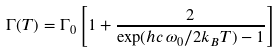Convert formula to latex. <formula><loc_0><loc_0><loc_500><loc_500>\Gamma ( T ) = \Gamma _ { 0 } \left [ 1 + \frac { 2 } { \exp ( h c \, \omega _ { 0 } / 2 k _ { B } T ) - 1 } \right ]</formula> 